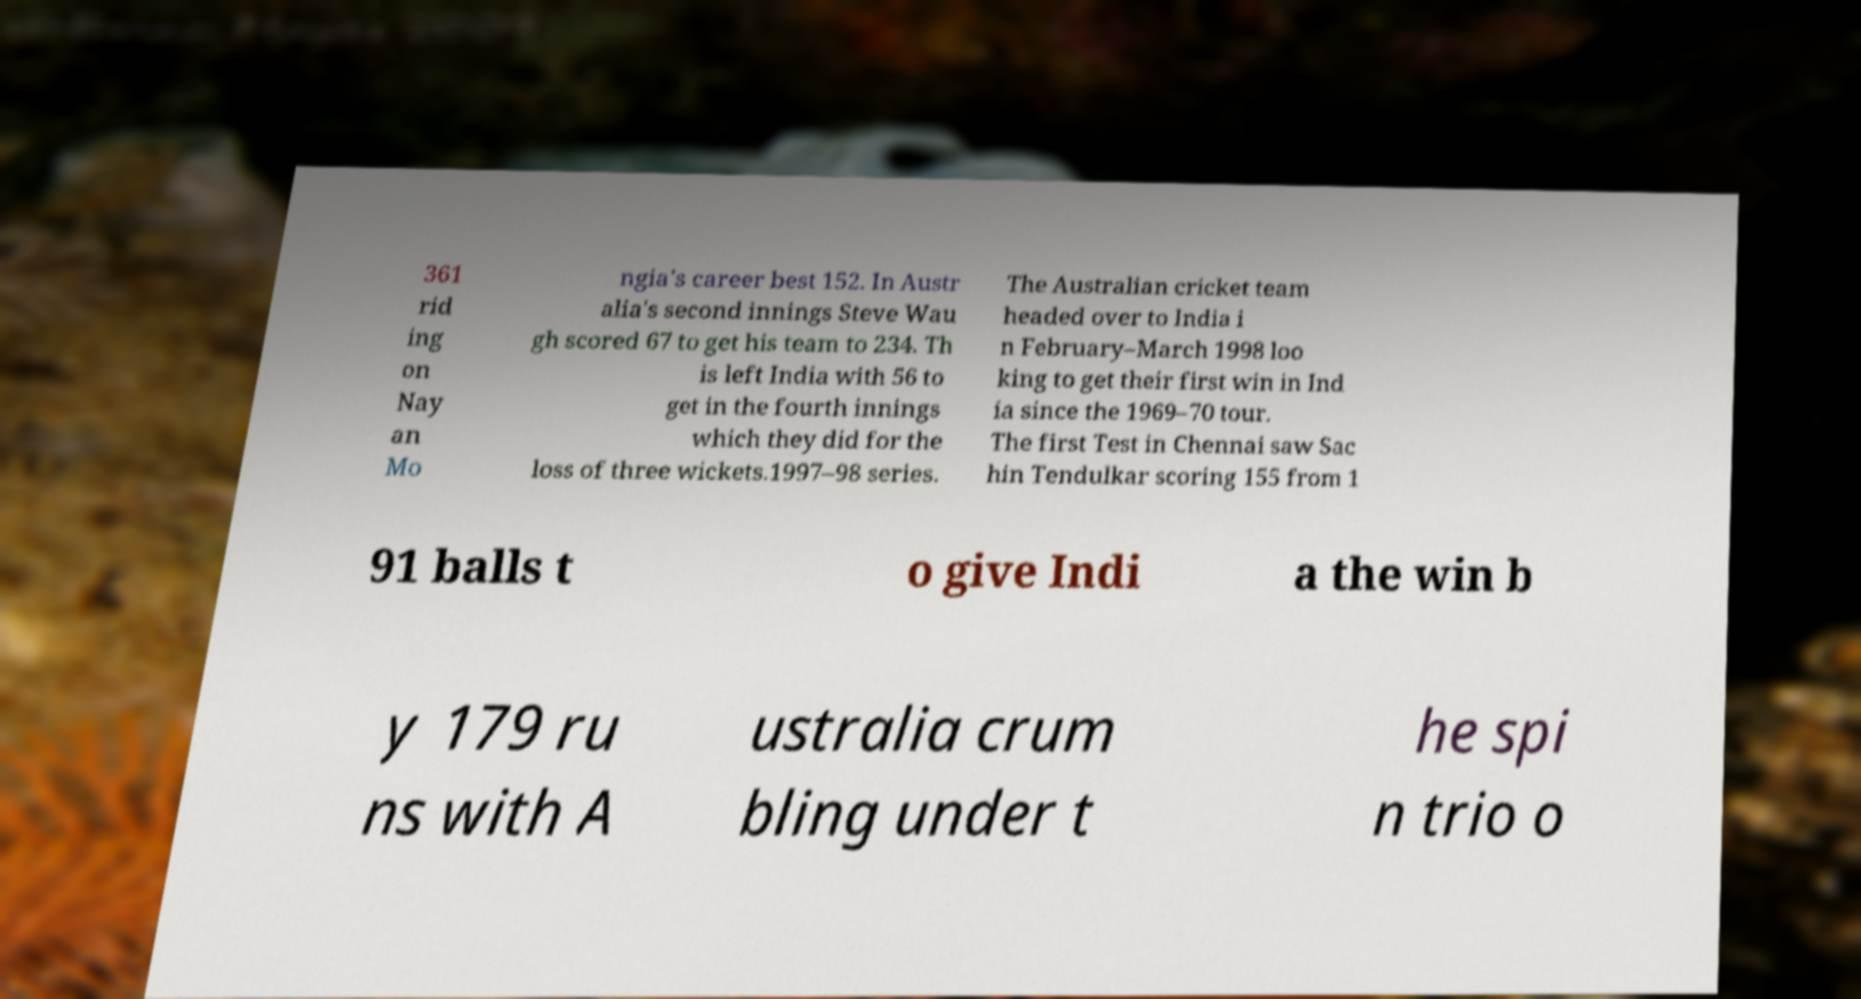Can you read and provide the text displayed in the image?This photo seems to have some interesting text. Can you extract and type it out for me? 361 rid ing on Nay an Mo ngia's career best 152. In Austr alia's second innings Steve Wau gh scored 67 to get his team to 234. Th is left India with 56 to get in the fourth innings which they did for the loss of three wickets.1997–98 series. The Australian cricket team headed over to India i n February–March 1998 loo king to get their first win in Ind ia since the 1969–70 tour. The first Test in Chennai saw Sac hin Tendulkar scoring 155 from 1 91 balls t o give Indi a the win b y 179 ru ns with A ustralia crum bling under t he spi n trio o 